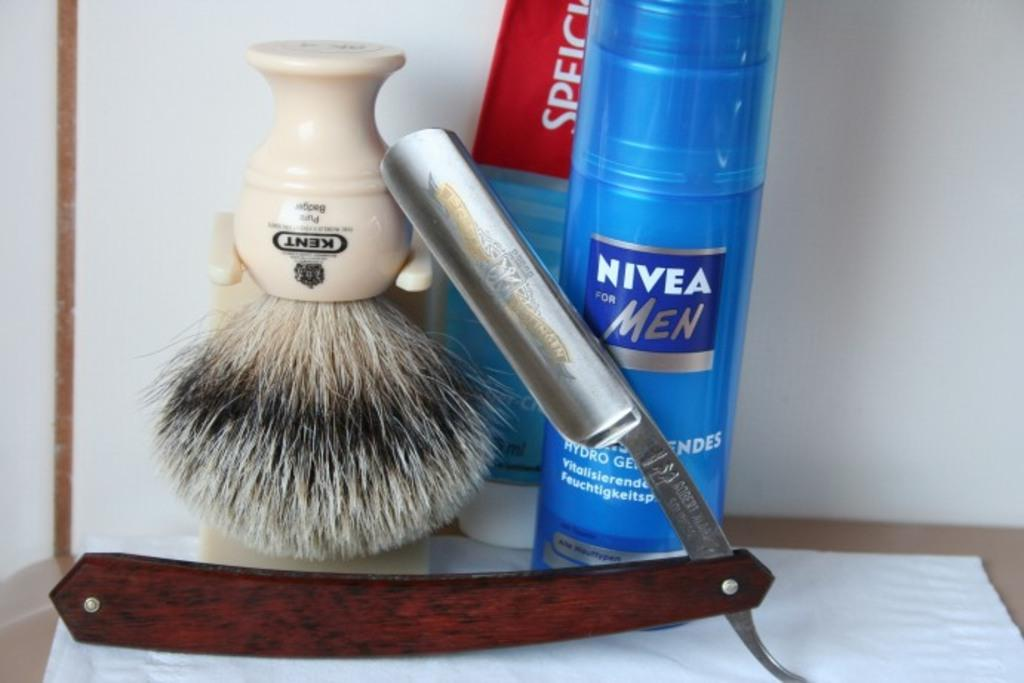Provide a one-sentence caption for the provided image. A large blue bottle of Nivea for Men sits behind a safety razor. 